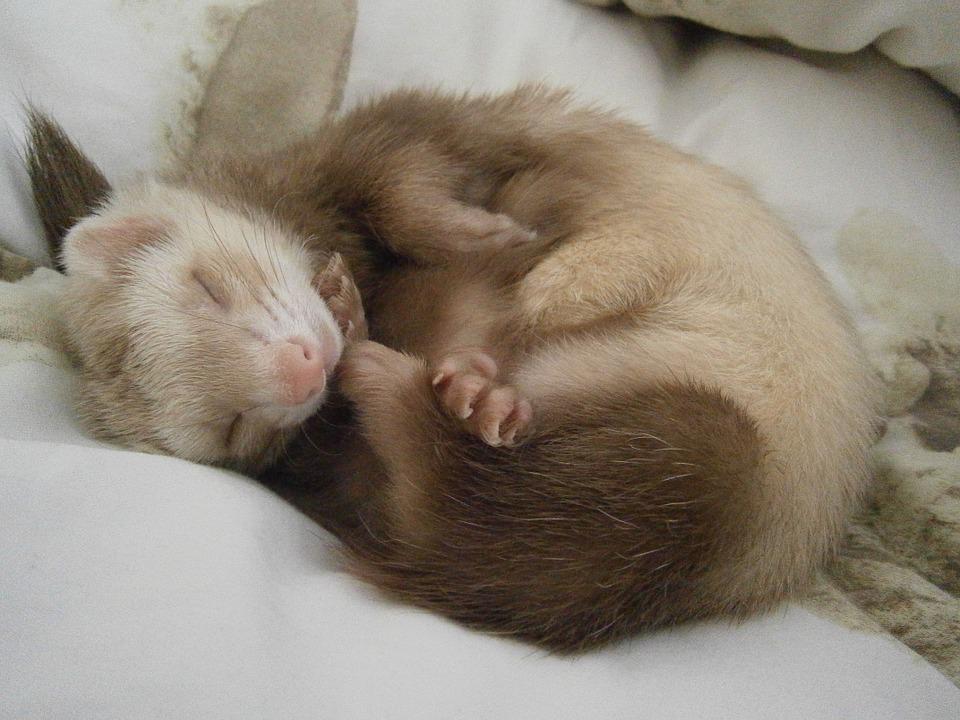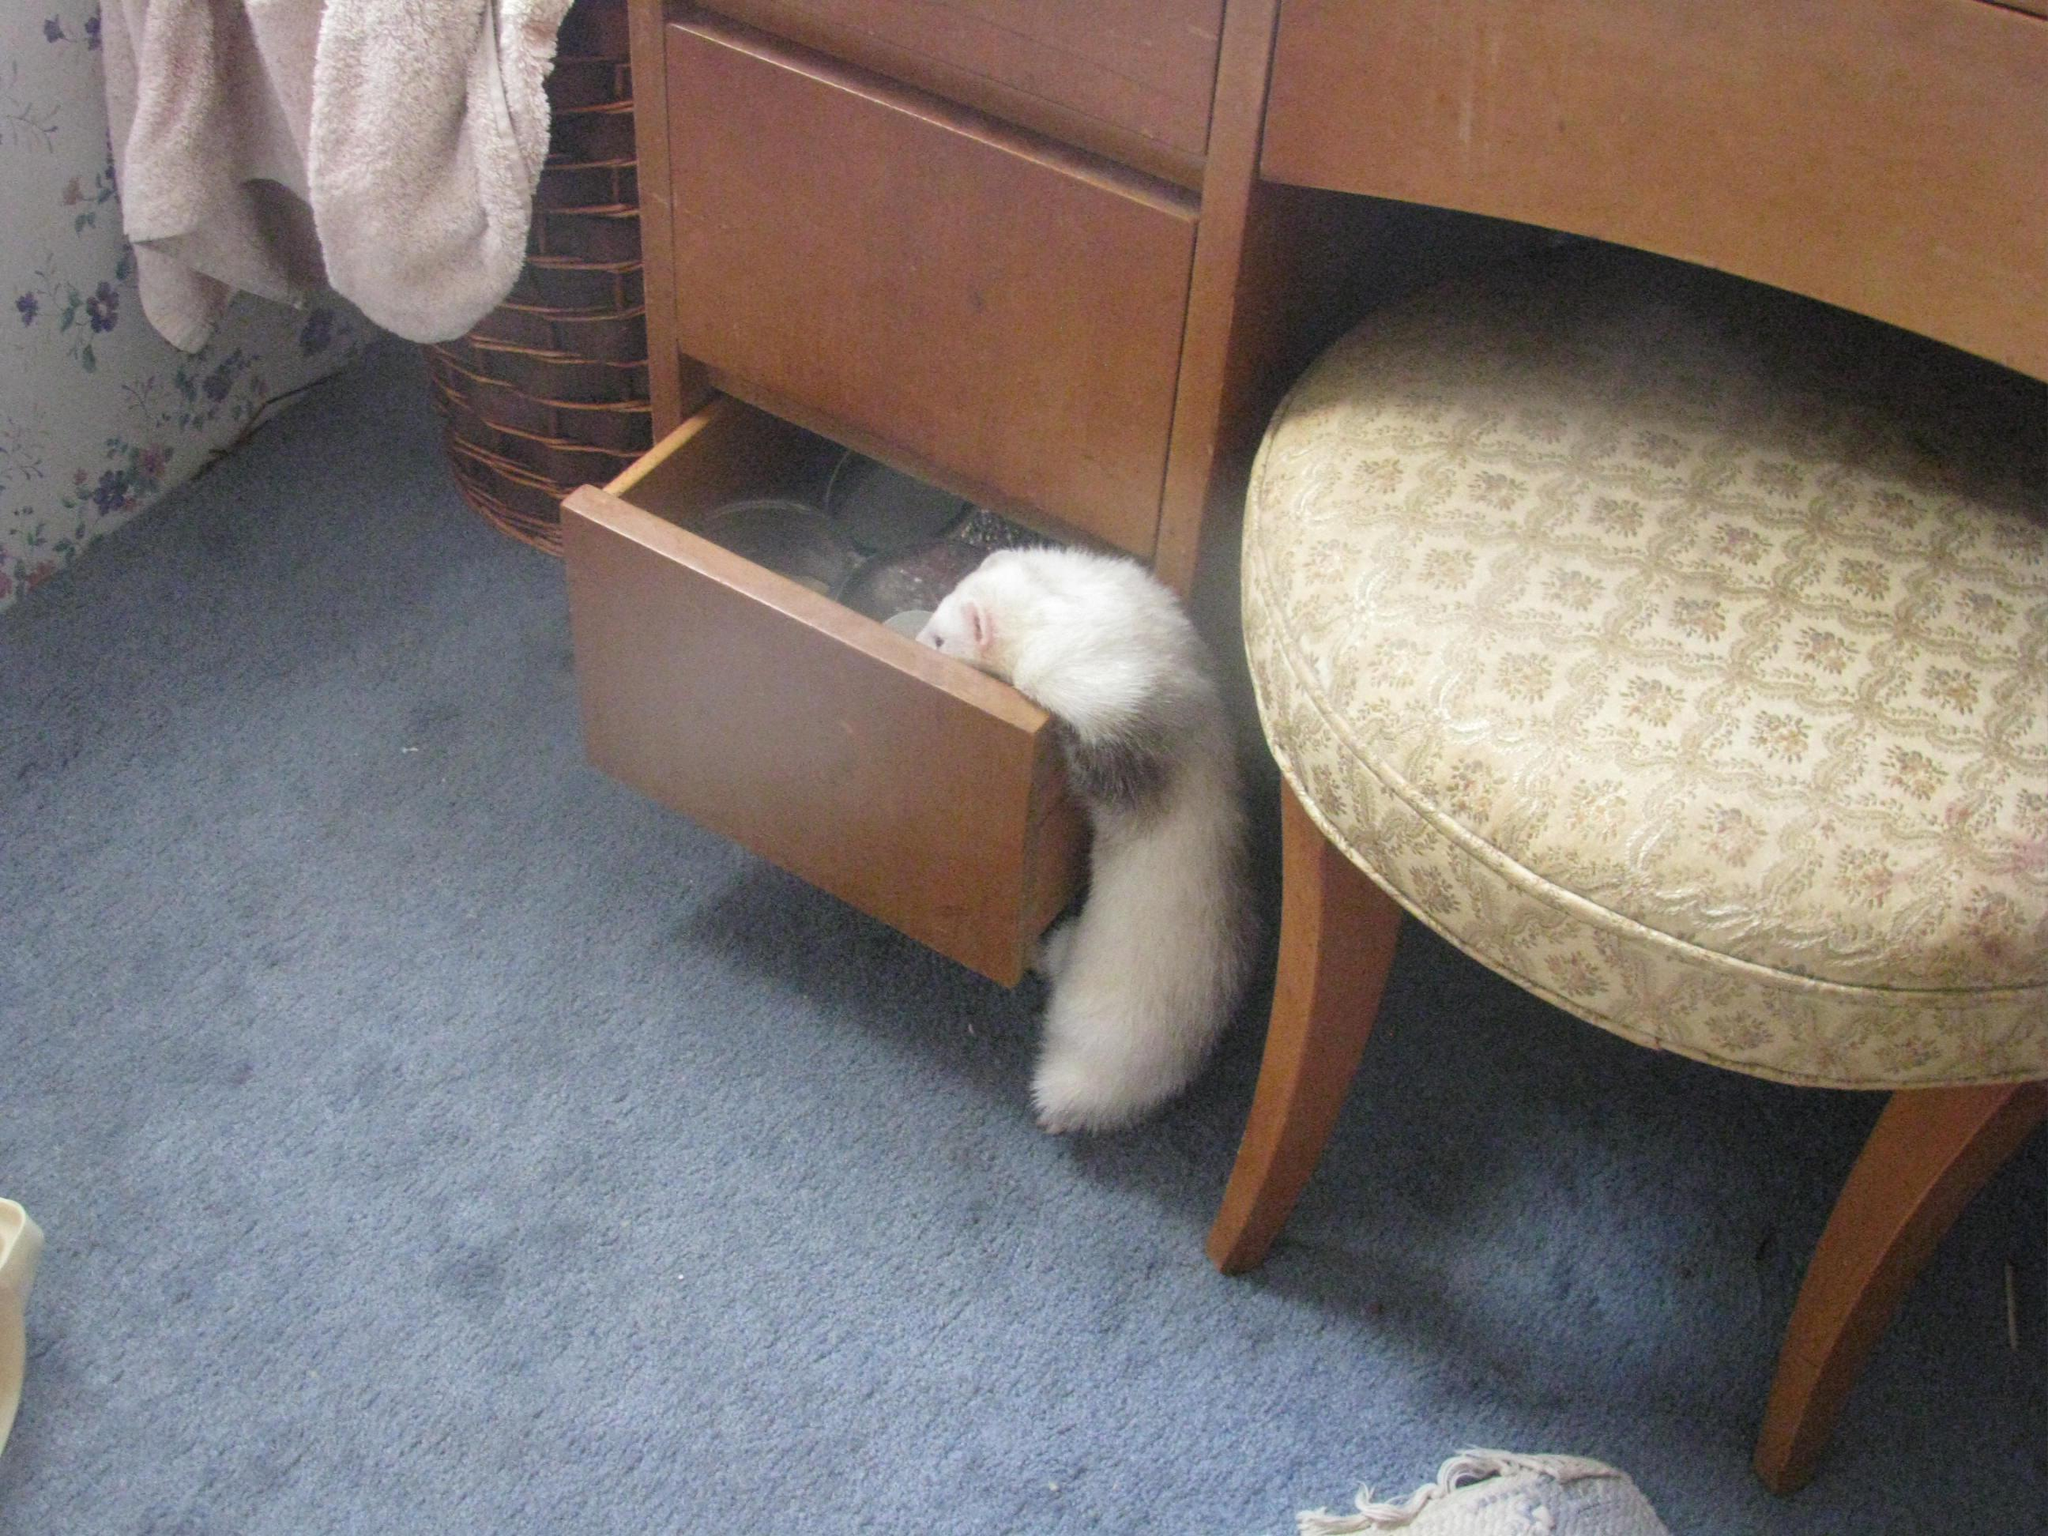The first image is the image on the left, the second image is the image on the right. Given the left and right images, does the statement "The left image contains one sleeping ferret." hold true? Answer yes or no. Yes. The first image is the image on the left, the second image is the image on the right. For the images displayed, is the sentence "At least one of the ferrets is wearing something on its head." factually correct? Answer yes or no. No. 